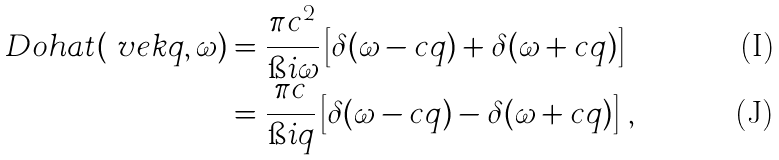<formula> <loc_0><loc_0><loc_500><loc_500>\ D o h a t ( \ v e k q , \omega ) & = \frac { \pi c ^ { 2 } } { \i i \omega } \left [ \delta ( \omega - c q ) + \delta ( \omega + c q ) \right ] \\ & = \frac { \pi c } { \i i q } \left [ \delta ( \omega - c q ) - \delta ( \omega + c q ) \right ] \, ,</formula> 